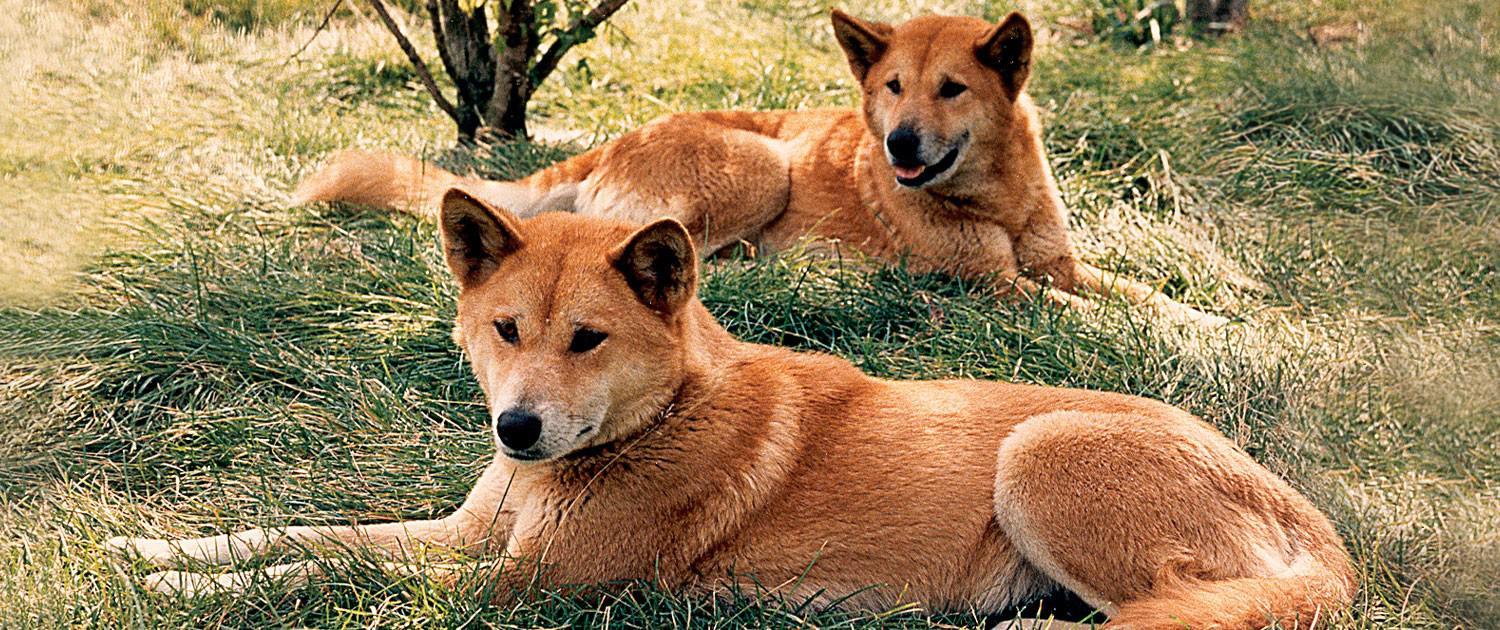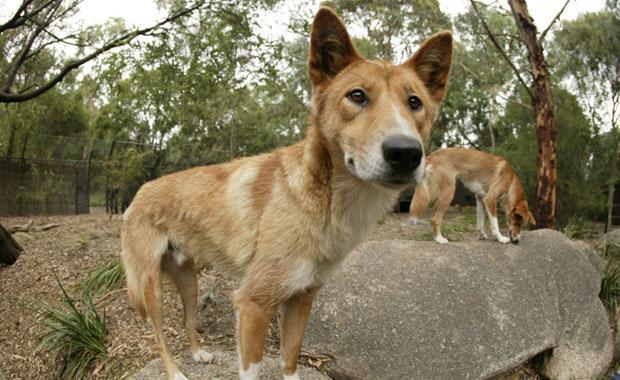The first image is the image on the left, the second image is the image on the right. For the images displayed, is the sentence "Two orange dogs are reclining in similar positions near one another." factually correct? Answer yes or no. Yes. The first image is the image on the left, the second image is the image on the right. Evaluate the accuracy of this statement regarding the images: "Two wild dogs are lying outside in the image on the left.". Is it true? Answer yes or no. Yes. 